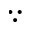Convert formula to latex. <formula><loc_0><loc_0><loc_500><loc_500>\because</formula> 